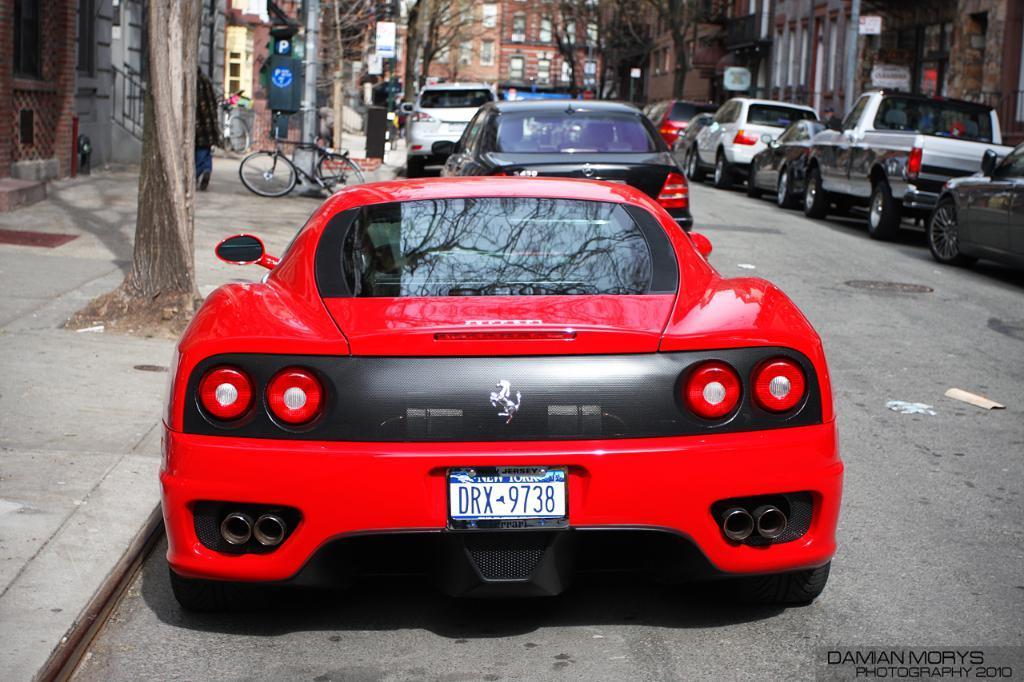In one or two sentences, can you explain what this image depicts? This is an outside view. On the right side there are some cars on the road. On the left side there are some trees, poles and a bicycle on the footpath. On both sides of the road there are many buildings. 